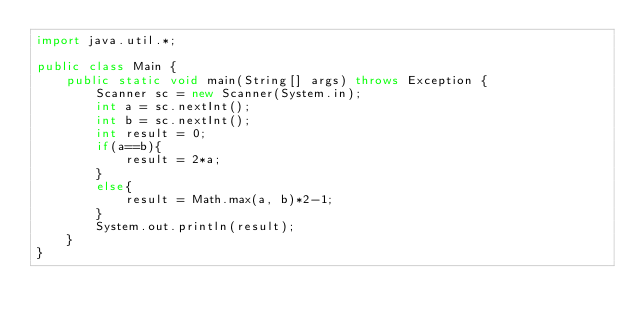<code> <loc_0><loc_0><loc_500><loc_500><_Java_>import java.util.*;

public class Main {
    public static void main(String[] args) throws Exception {
        Scanner sc = new Scanner(System.in);
        int a = sc.nextInt();
        int b = sc.nextInt();
        int result = 0;
        if(a==b){
            result = 2*a;
        }
        else{
            result = Math.max(a, b)*2-1;
        }
        System.out.println(result);
    }
}</code> 